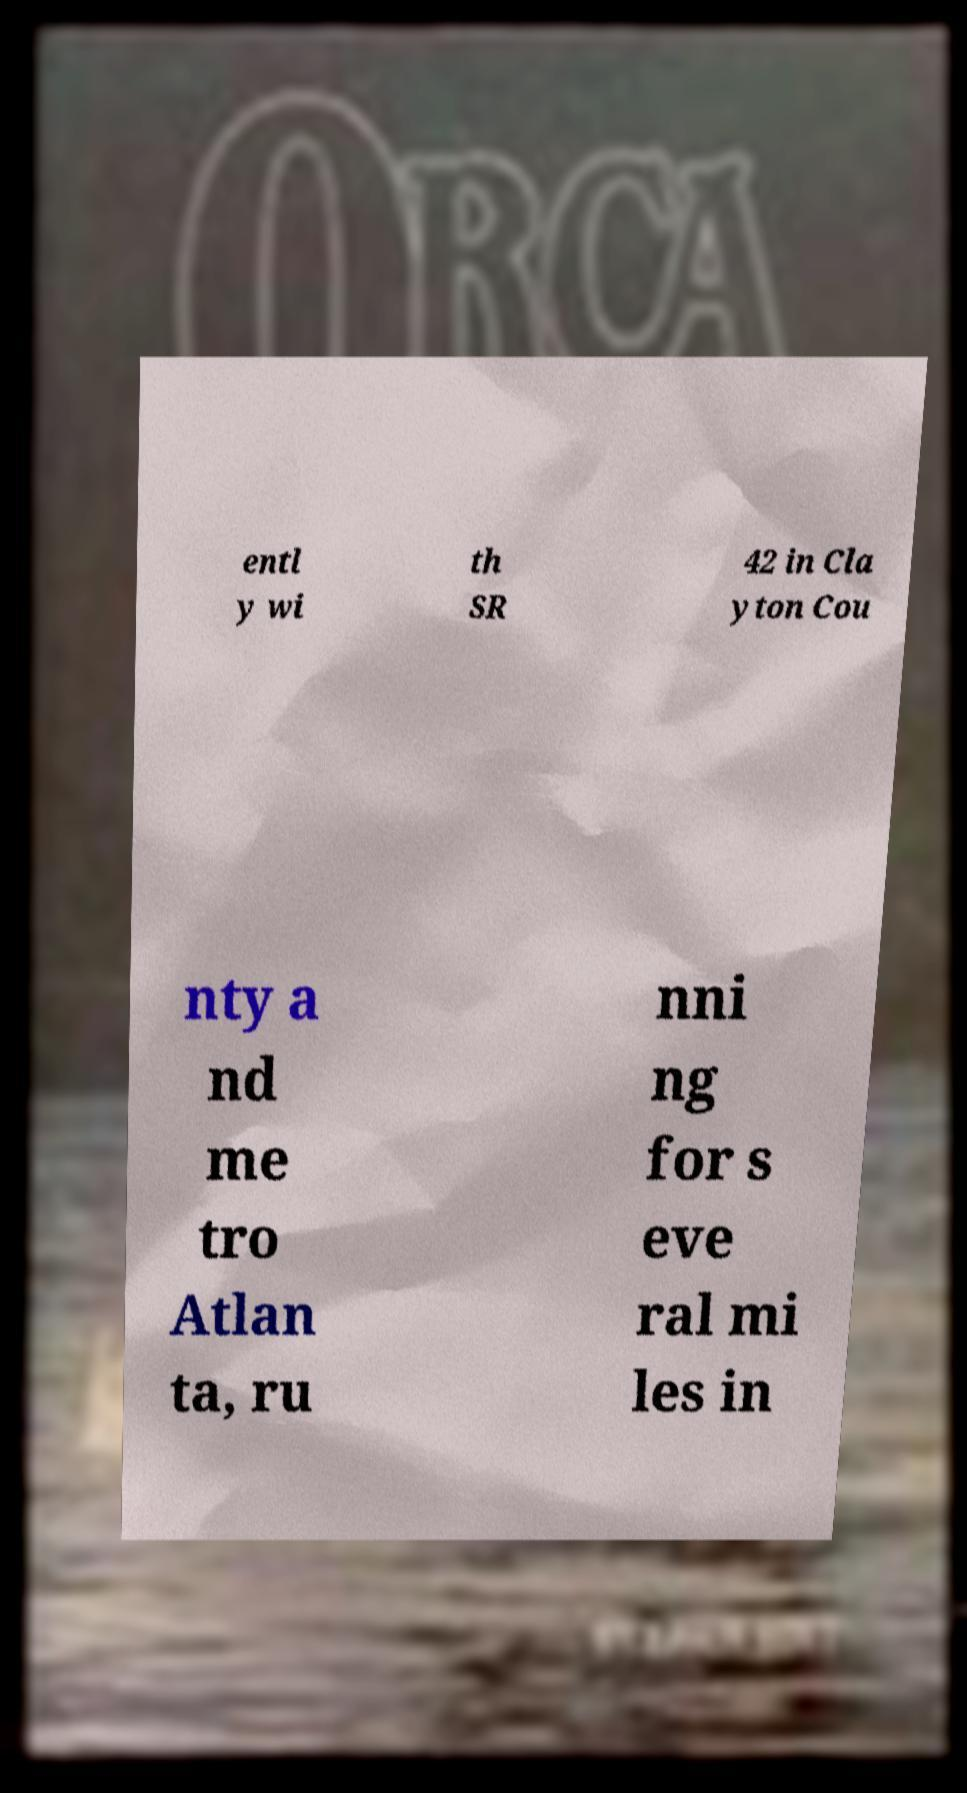Could you extract and type out the text from this image? entl y wi th SR 42 in Cla yton Cou nty a nd me tro Atlan ta, ru nni ng for s eve ral mi les in 